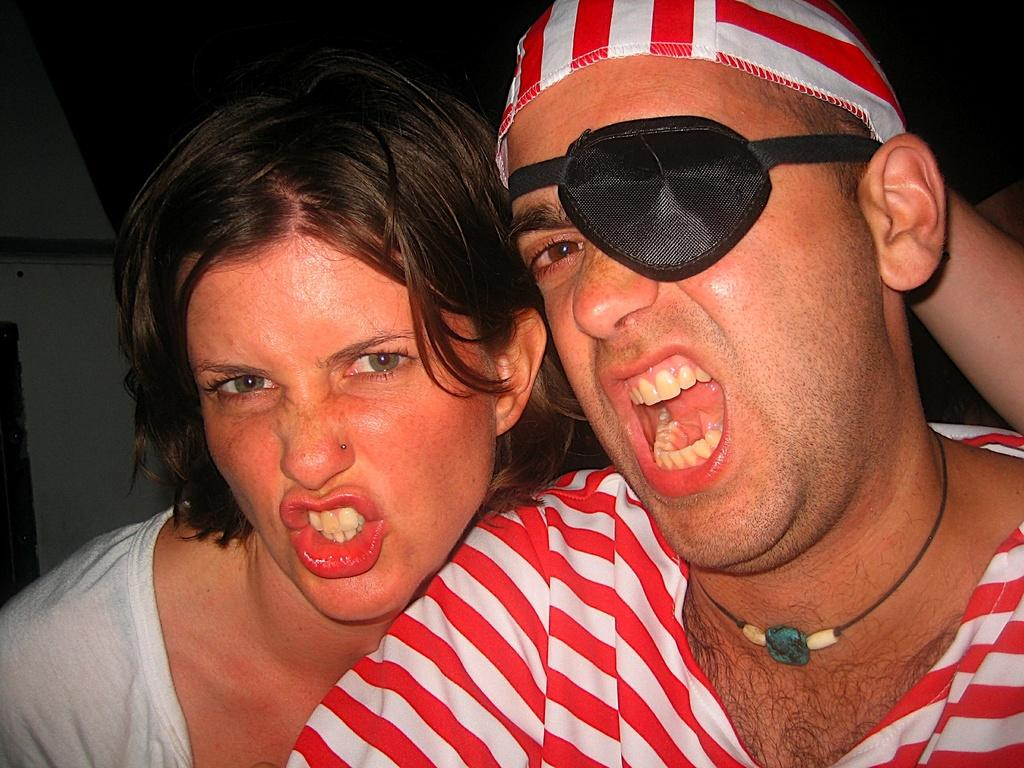What is the person in the image wearing on their eyes? The person in the image is wearing an eye mask. What else is the person wearing on their head? The person is also wearing a cap. Can you describe the clothing of the other person in the image? The other person in the image is wearing a white shirt. What can be seen in the background of the image? There is a wall visible in the background of the image. What type of jar is being used to create the mist in the image? There is no jar or mist present in the image. 